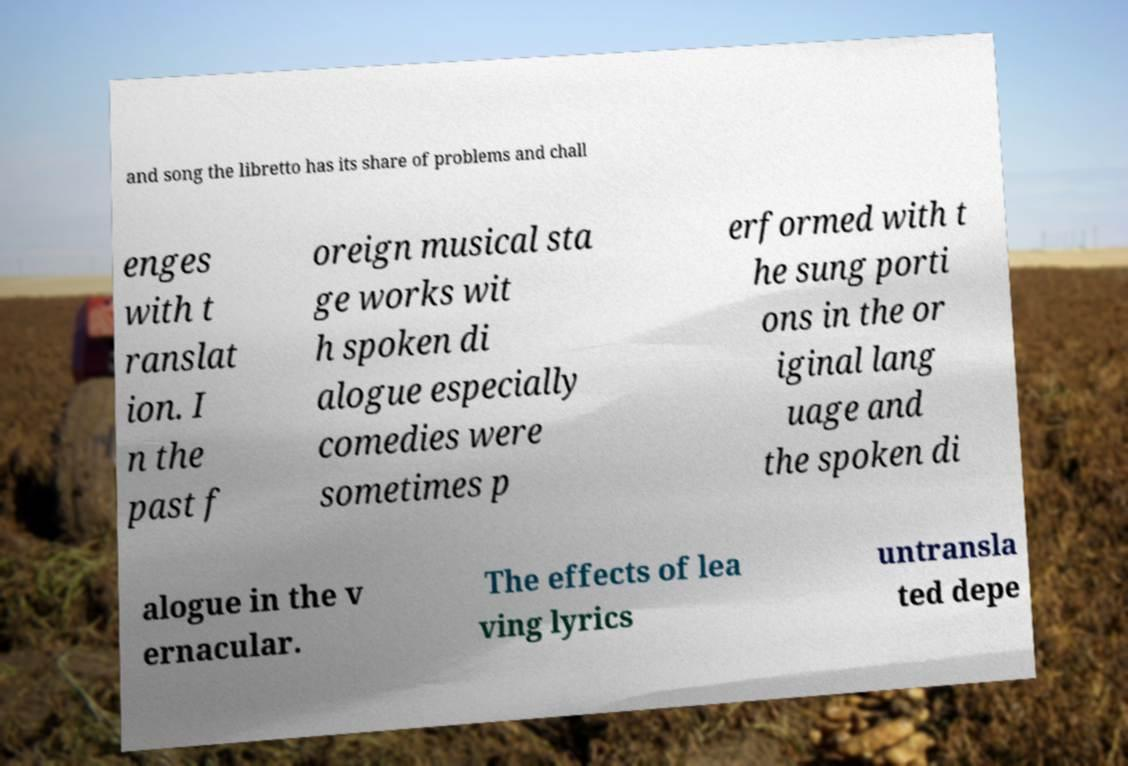Please identify and transcribe the text found in this image. and song the libretto has its share of problems and chall enges with t ranslat ion. I n the past f oreign musical sta ge works wit h spoken di alogue especially comedies were sometimes p erformed with t he sung porti ons in the or iginal lang uage and the spoken di alogue in the v ernacular. The effects of lea ving lyrics untransla ted depe 